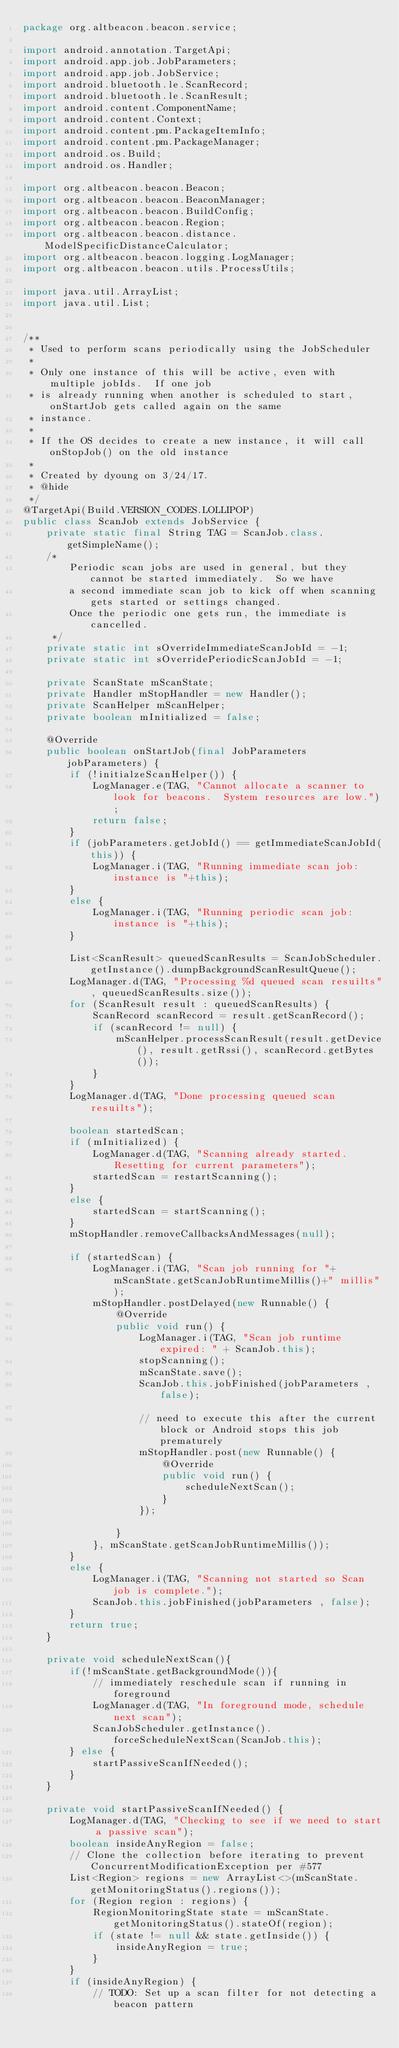<code> <loc_0><loc_0><loc_500><loc_500><_Java_>package org.altbeacon.beacon.service;

import android.annotation.TargetApi;
import android.app.job.JobParameters;
import android.app.job.JobService;
import android.bluetooth.le.ScanRecord;
import android.bluetooth.le.ScanResult;
import android.content.ComponentName;
import android.content.Context;
import android.content.pm.PackageItemInfo;
import android.content.pm.PackageManager;
import android.os.Build;
import android.os.Handler;

import org.altbeacon.beacon.Beacon;
import org.altbeacon.beacon.BeaconManager;
import org.altbeacon.beacon.BuildConfig;
import org.altbeacon.beacon.Region;
import org.altbeacon.beacon.distance.ModelSpecificDistanceCalculator;
import org.altbeacon.beacon.logging.LogManager;
import org.altbeacon.beacon.utils.ProcessUtils;

import java.util.ArrayList;
import java.util.List;


/**
 * Used to perform scans periodically using the JobScheduler
 *
 * Only one instance of this will be active, even with multiple jobIds.  If one job
 * is already running when another is scheduled to start, onStartJob gets called again on the same
 * instance.
 *
 * If the OS decides to create a new instance, it will call onStopJob() on the old instance
 *
 * Created by dyoung on 3/24/17.
 * @hide
 */
@TargetApi(Build.VERSION_CODES.LOLLIPOP)
public class ScanJob extends JobService {
    private static final String TAG = ScanJob.class.getSimpleName();
    /*
        Periodic scan jobs are used in general, but they cannot be started immediately.  So we have
        a second immediate scan job to kick off when scanning gets started or settings changed.
        Once the periodic one gets run, the immediate is cancelled.
     */
    private static int sOverrideImmediateScanJobId = -1;
    private static int sOverridePeriodicScanJobId = -1;

    private ScanState mScanState;
    private Handler mStopHandler = new Handler();
    private ScanHelper mScanHelper;
    private boolean mInitialized = false;

    @Override
    public boolean onStartJob(final JobParameters jobParameters) {
        if (!initialzeScanHelper()) {
            LogManager.e(TAG, "Cannot allocate a scanner to look for beacons.  System resources are low.");
            return false;
        }
        if (jobParameters.getJobId() == getImmediateScanJobId(this)) {
            LogManager.i(TAG, "Running immediate scan job: instance is "+this);
        }
        else {
            LogManager.i(TAG, "Running periodic scan job: instance is "+this);
        }

        List<ScanResult> queuedScanResults = ScanJobScheduler.getInstance().dumpBackgroundScanResultQueue();
        LogManager.d(TAG, "Processing %d queued scan resuilts", queuedScanResults.size());
        for (ScanResult result : queuedScanResults) {
            ScanRecord scanRecord = result.getScanRecord();
            if (scanRecord != null) {
                mScanHelper.processScanResult(result.getDevice(), result.getRssi(), scanRecord.getBytes());
            }
        }
        LogManager.d(TAG, "Done processing queued scan resuilts");

        boolean startedScan;
        if (mInitialized) {
            LogManager.d(TAG, "Scanning already started.  Resetting for current parameters");
            startedScan = restartScanning();
        }
        else {
            startedScan = startScanning();
        }
        mStopHandler.removeCallbacksAndMessages(null);

        if (startedScan) {
            LogManager.i(TAG, "Scan job running for "+mScanState.getScanJobRuntimeMillis()+" millis");
            mStopHandler.postDelayed(new Runnable() {
                @Override
                public void run() {
                    LogManager.i(TAG, "Scan job runtime expired: " + ScanJob.this);
                    stopScanning();
                    mScanState.save();
                    ScanJob.this.jobFinished(jobParameters , false);

                    // need to execute this after the current block or Android stops this job prematurely
                    mStopHandler.post(new Runnable() {
                        @Override
                        public void run() {
                            scheduleNextScan();
                        }
                    });

                }
            }, mScanState.getScanJobRuntimeMillis());
        }
        else {
            LogManager.i(TAG, "Scanning not started so Scan job is complete.");
            ScanJob.this.jobFinished(jobParameters , false);
        }
        return true;
    }

    private void scheduleNextScan(){
        if(!mScanState.getBackgroundMode()){
            // immediately reschedule scan if running in foreground
            LogManager.d(TAG, "In foreground mode, schedule next scan");
            ScanJobScheduler.getInstance().forceScheduleNextScan(ScanJob.this);
        } else {
            startPassiveScanIfNeeded();
        }
    }

    private void startPassiveScanIfNeeded() {
        LogManager.d(TAG, "Checking to see if we need to start a passive scan");
        boolean insideAnyRegion = false;
        // Clone the collection before iterating to prevent ConcurrentModificationException per #577
        List<Region> regions = new ArrayList<>(mScanState.getMonitoringStatus().regions());
        for (Region region : regions) {
            RegionMonitoringState state = mScanState.getMonitoringStatus().stateOf(region);
            if (state != null && state.getInside()) {
                insideAnyRegion = true;
            }
        }
        if (insideAnyRegion) {
            // TODO: Set up a scan filter for not detecting a beacon pattern</code> 